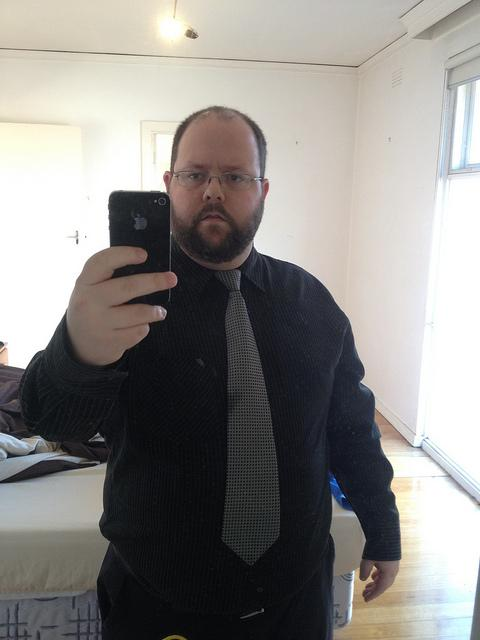What is the man taking? selfie 